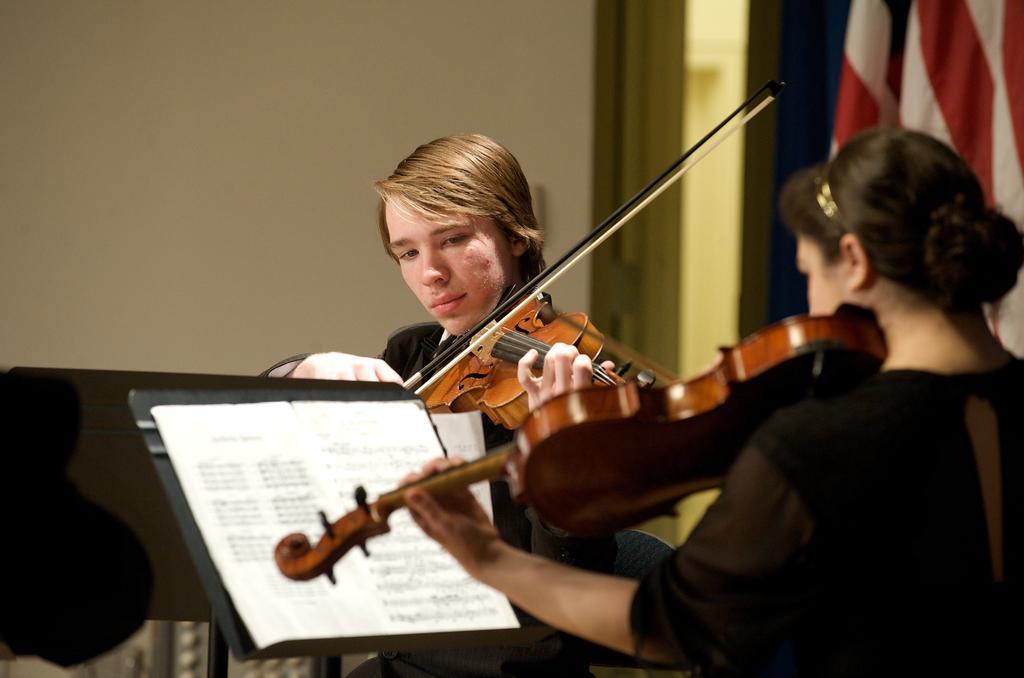In one or two sentences, can you explain what this image depicts? In this picture there are two people playing the violin there is a stand before them and they are some papers on it 